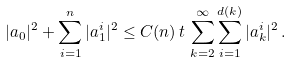Convert formula to latex. <formula><loc_0><loc_0><loc_500><loc_500>| a _ { 0 } | ^ { 2 } + \sum _ { i = 1 } ^ { n } | a ^ { i } _ { 1 } | ^ { 2 } \leq C ( n ) \, t \, \sum _ { k = 2 } ^ { \infty } \sum _ { i = 1 } ^ { d ( k ) } | a _ { k } ^ { i } | ^ { 2 } \, .</formula> 